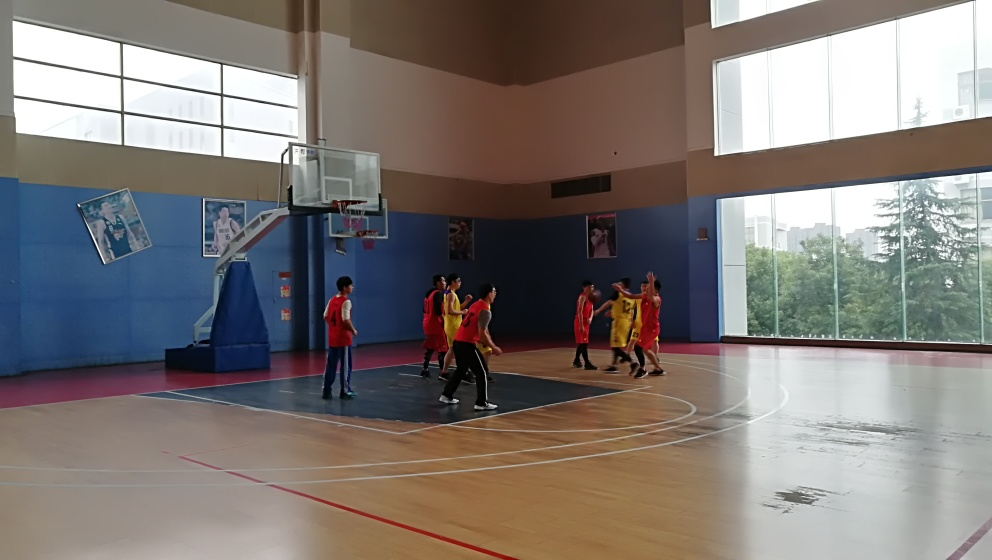Are the colors in this photo rich? The colors in this photo have a moderate level of richness. While the photo isn’t overly saturated, there is a decent contrast between the warm tones of the players' outfits and the cooler colors of the walls and floor. The natural light from the windows adds a softness that balances the tones throughout the scene. 